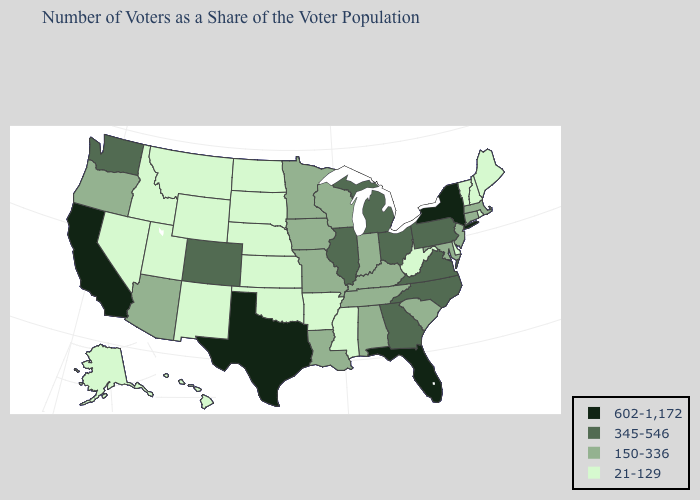Name the states that have a value in the range 21-129?
Write a very short answer. Alaska, Arkansas, Delaware, Hawaii, Idaho, Kansas, Maine, Mississippi, Montana, Nebraska, Nevada, New Hampshire, New Mexico, North Dakota, Oklahoma, Rhode Island, South Dakota, Utah, Vermont, West Virginia, Wyoming. What is the lowest value in states that border Arizona?
Be succinct. 21-129. Does the first symbol in the legend represent the smallest category?
Answer briefly. No. Does the map have missing data?
Be succinct. No. Name the states that have a value in the range 345-546?
Answer briefly. Colorado, Georgia, Illinois, Michigan, North Carolina, Ohio, Pennsylvania, Virginia, Washington. What is the value of Rhode Island?
Short answer required. 21-129. Among the states that border Wisconsin , does Minnesota have the lowest value?
Keep it brief. Yes. Which states hav the highest value in the MidWest?
Be succinct. Illinois, Michigan, Ohio. What is the value of Hawaii?
Give a very brief answer. 21-129. What is the value of New York?
Answer briefly. 602-1,172. Is the legend a continuous bar?
Keep it brief. No. What is the value of Maryland?
Write a very short answer. 150-336. Which states hav the highest value in the South?
Be succinct. Florida, Texas. Does California have the highest value in the USA?
Keep it brief. Yes. What is the value of Washington?
Write a very short answer. 345-546. 